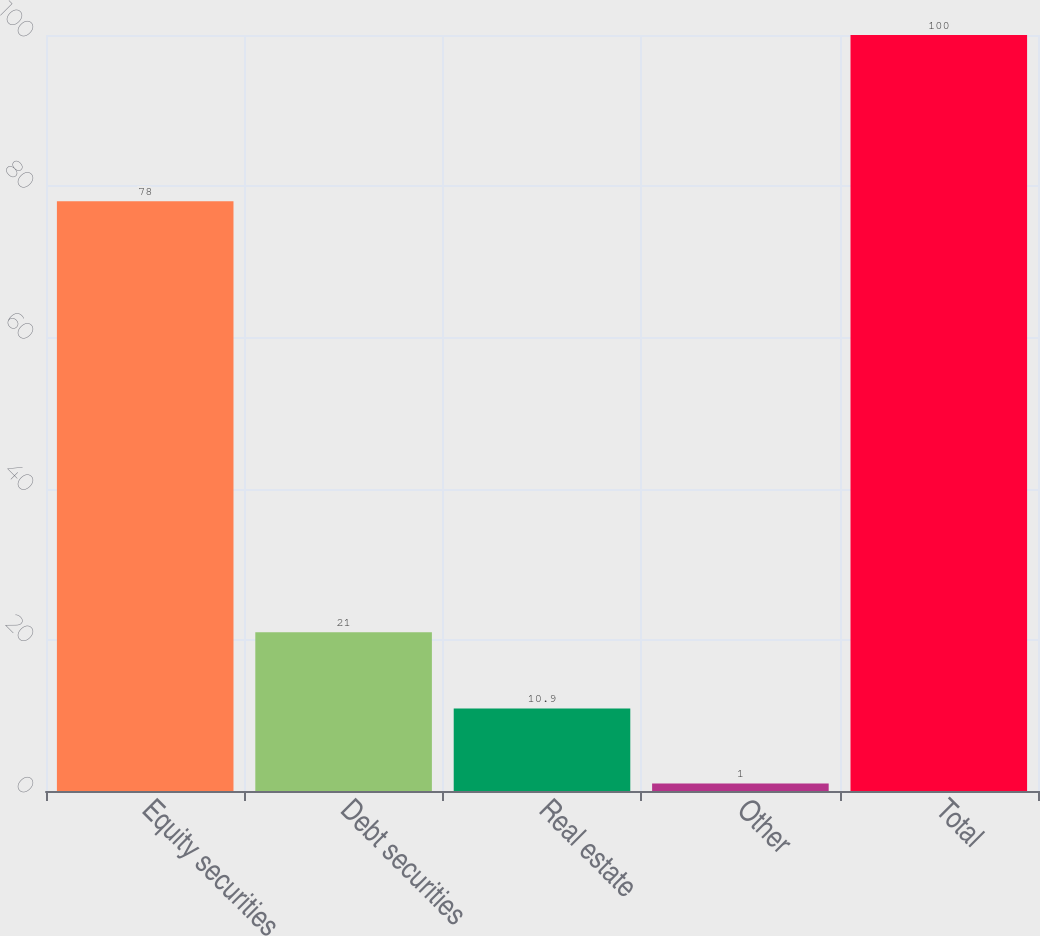<chart> <loc_0><loc_0><loc_500><loc_500><bar_chart><fcel>Equity securities<fcel>Debt securities<fcel>Real estate<fcel>Other<fcel>Total<nl><fcel>78<fcel>21<fcel>10.9<fcel>1<fcel>100<nl></chart> 